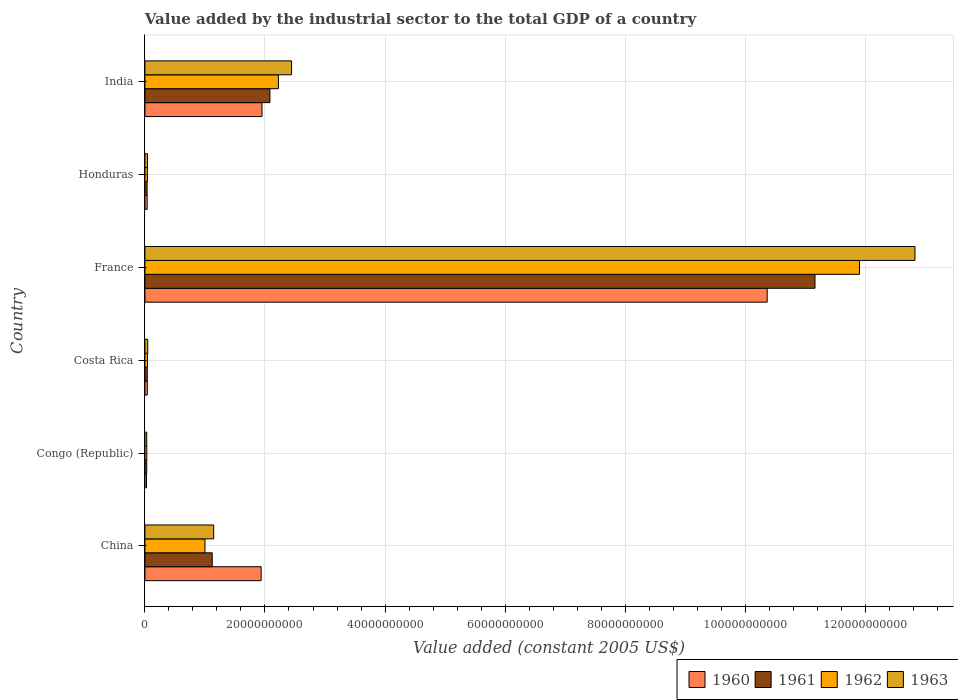How many different coloured bars are there?
Make the answer very short. 4. How many bars are there on the 2nd tick from the bottom?
Offer a terse response. 4. What is the label of the 2nd group of bars from the top?
Provide a succinct answer. Honduras. In how many cases, is the number of bars for a given country not equal to the number of legend labels?
Your answer should be very brief. 0. What is the value added by the industrial sector in 1961 in France?
Give a very brief answer. 1.12e+11. Across all countries, what is the maximum value added by the industrial sector in 1960?
Your answer should be very brief. 1.04e+11. Across all countries, what is the minimum value added by the industrial sector in 1962?
Provide a succinct answer. 3.12e+08. In which country was the value added by the industrial sector in 1962 minimum?
Offer a very short reply. Congo (Republic). What is the total value added by the industrial sector in 1960 in the graph?
Make the answer very short. 1.44e+11. What is the difference between the value added by the industrial sector in 1962 in China and that in France?
Offer a very short reply. -1.09e+11. What is the difference between the value added by the industrial sector in 1960 in India and the value added by the industrial sector in 1962 in Congo (Republic)?
Keep it short and to the point. 1.92e+1. What is the average value added by the industrial sector in 1963 per country?
Your response must be concise. 2.76e+1. What is the difference between the value added by the industrial sector in 1961 and value added by the industrial sector in 1962 in Congo (Republic)?
Your answer should be compact. -1.47e+07. In how many countries, is the value added by the industrial sector in 1960 greater than 100000000000 US$?
Your response must be concise. 1. What is the ratio of the value added by the industrial sector in 1962 in Congo (Republic) to that in France?
Offer a terse response. 0. Is the value added by the industrial sector in 1960 in Costa Rica less than that in India?
Your answer should be very brief. Yes. Is the difference between the value added by the industrial sector in 1961 in France and India greater than the difference between the value added by the industrial sector in 1962 in France and India?
Offer a very short reply. No. What is the difference between the highest and the second highest value added by the industrial sector in 1963?
Give a very brief answer. 1.04e+11. What is the difference between the highest and the lowest value added by the industrial sector in 1961?
Provide a short and direct response. 1.11e+11. In how many countries, is the value added by the industrial sector in 1960 greater than the average value added by the industrial sector in 1960 taken over all countries?
Provide a succinct answer. 1. How many bars are there?
Keep it short and to the point. 24. What is the difference between two consecutive major ticks on the X-axis?
Your answer should be compact. 2.00e+1. Are the values on the major ticks of X-axis written in scientific E-notation?
Your response must be concise. No. Does the graph contain any zero values?
Ensure brevity in your answer.  No. How many legend labels are there?
Your answer should be very brief. 4. How are the legend labels stacked?
Your answer should be very brief. Horizontal. What is the title of the graph?
Make the answer very short. Value added by the industrial sector to the total GDP of a country. Does "2003" appear as one of the legend labels in the graph?
Offer a very short reply. No. What is the label or title of the X-axis?
Make the answer very short. Value added (constant 2005 US$). What is the Value added (constant 2005 US$) of 1960 in China?
Your response must be concise. 1.94e+1. What is the Value added (constant 2005 US$) in 1961 in China?
Your response must be concise. 1.12e+1. What is the Value added (constant 2005 US$) of 1962 in China?
Keep it short and to the point. 1.00e+1. What is the Value added (constant 2005 US$) of 1963 in China?
Your answer should be very brief. 1.15e+1. What is the Value added (constant 2005 US$) of 1960 in Congo (Republic)?
Keep it short and to the point. 2.61e+08. What is the Value added (constant 2005 US$) of 1961 in Congo (Republic)?
Ensure brevity in your answer.  2.98e+08. What is the Value added (constant 2005 US$) in 1962 in Congo (Republic)?
Provide a succinct answer. 3.12e+08. What is the Value added (constant 2005 US$) in 1963 in Congo (Republic)?
Give a very brief answer. 3.00e+08. What is the Value added (constant 2005 US$) in 1960 in Costa Rica?
Your response must be concise. 3.98e+08. What is the Value added (constant 2005 US$) of 1961 in Costa Rica?
Your response must be concise. 3.94e+08. What is the Value added (constant 2005 US$) of 1962 in Costa Rica?
Provide a short and direct response. 4.27e+08. What is the Value added (constant 2005 US$) of 1963 in Costa Rica?
Make the answer very short. 4.68e+08. What is the Value added (constant 2005 US$) in 1960 in France?
Provide a succinct answer. 1.04e+11. What is the Value added (constant 2005 US$) of 1961 in France?
Your response must be concise. 1.12e+11. What is the Value added (constant 2005 US$) of 1962 in France?
Provide a short and direct response. 1.19e+11. What is the Value added (constant 2005 US$) of 1963 in France?
Your answer should be very brief. 1.28e+11. What is the Value added (constant 2005 US$) of 1960 in Honduras?
Provide a succinct answer. 3.75e+08. What is the Value added (constant 2005 US$) in 1961 in Honduras?
Offer a very short reply. 3.66e+08. What is the Value added (constant 2005 US$) in 1962 in Honduras?
Ensure brevity in your answer.  4.16e+08. What is the Value added (constant 2005 US$) in 1963 in Honduras?
Make the answer very short. 4.23e+08. What is the Value added (constant 2005 US$) in 1960 in India?
Your answer should be compact. 1.95e+1. What is the Value added (constant 2005 US$) of 1961 in India?
Give a very brief answer. 2.08e+1. What is the Value added (constant 2005 US$) in 1962 in India?
Keep it short and to the point. 2.22e+1. What is the Value added (constant 2005 US$) of 1963 in India?
Make the answer very short. 2.44e+1. Across all countries, what is the maximum Value added (constant 2005 US$) in 1960?
Your answer should be very brief. 1.04e+11. Across all countries, what is the maximum Value added (constant 2005 US$) in 1961?
Offer a very short reply. 1.12e+11. Across all countries, what is the maximum Value added (constant 2005 US$) of 1962?
Provide a short and direct response. 1.19e+11. Across all countries, what is the maximum Value added (constant 2005 US$) in 1963?
Your answer should be compact. 1.28e+11. Across all countries, what is the minimum Value added (constant 2005 US$) of 1960?
Your answer should be very brief. 2.61e+08. Across all countries, what is the minimum Value added (constant 2005 US$) of 1961?
Make the answer very short. 2.98e+08. Across all countries, what is the minimum Value added (constant 2005 US$) in 1962?
Offer a very short reply. 3.12e+08. Across all countries, what is the minimum Value added (constant 2005 US$) in 1963?
Your answer should be very brief. 3.00e+08. What is the total Value added (constant 2005 US$) of 1960 in the graph?
Offer a very short reply. 1.44e+11. What is the total Value added (constant 2005 US$) of 1961 in the graph?
Your answer should be very brief. 1.45e+11. What is the total Value added (constant 2005 US$) of 1962 in the graph?
Offer a terse response. 1.52e+11. What is the total Value added (constant 2005 US$) of 1963 in the graph?
Your answer should be compact. 1.65e+11. What is the difference between the Value added (constant 2005 US$) of 1960 in China and that in Congo (Republic)?
Your answer should be compact. 1.91e+1. What is the difference between the Value added (constant 2005 US$) in 1961 in China and that in Congo (Republic)?
Your answer should be compact. 1.09e+1. What is the difference between the Value added (constant 2005 US$) in 1962 in China and that in Congo (Republic)?
Keep it short and to the point. 9.69e+09. What is the difference between the Value added (constant 2005 US$) of 1963 in China and that in Congo (Republic)?
Keep it short and to the point. 1.12e+1. What is the difference between the Value added (constant 2005 US$) in 1960 in China and that in Costa Rica?
Your answer should be compact. 1.90e+1. What is the difference between the Value added (constant 2005 US$) in 1961 in China and that in Costa Rica?
Keep it short and to the point. 1.08e+1. What is the difference between the Value added (constant 2005 US$) in 1962 in China and that in Costa Rica?
Ensure brevity in your answer.  9.58e+09. What is the difference between the Value added (constant 2005 US$) in 1963 in China and that in Costa Rica?
Provide a succinct answer. 1.10e+1. What is the difference between the Value added (constant 2005 US$) of 1960 in China and that in France?
Provide a short and direct response. -8.43e+1. What is the difference between the Value added (constant 2005 US$) of 1961 in China and that in France?
Your answer should be compact. -1.00e+11. What is the difference between the Value added (constant 2005 US$) in 1962 in China and that in France?
Your answer should be compact. -1.09e+11. What is the difference between the Value added (constant 2005 US$) in 1963 in China and that in France?
Offer a very short reply. -1.17e+11. What is the difference between the Value added (constant 2005 US$) in 1960 in China and that in Honduras?
Provide a short and direct response. 1.90e+1. What is the difference between the Value added (constant 2005 US$) in 1961 in China and that in Honduras?
Your answer should be very brief. 1.08e+1. What is the difference between the Value added (constant 2005 US$) of 1962 in China and that in Honduras?
Offer a terse response. 9.59e+09. What is the difference between the Value added (constant 2005 US$) in 1963 in China and that in Honduras?
Make the answer very short. 1.10e+1. What is the difference between the Value added (constant 2005 US$) of 1960 in China and that in India?
Your answer should be very brief. -1.35e+08. What is the difference between the Value added (constant 2005 US$) in 1961 in China and that in India?
Offer a very short reply. -9.61e+09. What is the difference between the Value added (constant 2005 US$) of 1962 in China and that in India?
Provide a short and direct response. -1.22e+1. What is the difference between the Value added (constant 2005 US$) in 1963 in China and that in India?
Your response must be concise. -1.30e+1. What is the difference between the Value added (constant 2005 US$) in 1960 in Congo (Republic) and that in Costa Rica?
Offer a very short reply. -1.36e+08. What is the difference between the Value added (constant 2005 US$) of 1961 in Congo (Republic) and that in Costa Rica?
Your answer should be compact. -9.59e+07. What is the difference between the Value added (constant 2005 US$) in 1962 in Congo (Republic) and that in Costa Rica?
Make the answer very short. -1.14e+08. What is the difference between the Value added (constant 2005 US$) of 1963 in Congo (Republic) and that in Costa Rica?
Give a very brief answer. -1.68e+08. What is the difference between the Value added (constant 2005 US$) of 1960 in Congo (Republic) and that in France?
Offer a very short reply. -1.03e+11. What is the difference between the Value added (constant 2005 US$) of 1961 in Congo (Republic) and that in France?
Your answer should be compact. -1.11e+11. What is the difference between the Value added (constant 2005 US$) in 1962 in Congo (Republic) and that in France?
Offer a very short reply. -1.19e+11. What is the difference between the Value added (constant 2005 US$) in 1963 in Congo (Republic) and that in France?
Ensure brevity in your answer.  -1.28e+11. What is the difference between the Value added (constant 2005 US$) of 1960 in Congo (Republic) and that in Honduras?
Give a very brief answer. -1.14e+08. What is the difference between the Value added (constant 2005 US$) of 1961 in Congo (Republic) and that in Honduras?
Your response must be concise. -6.81e+07. What is the difference between the Value added (constant 2005 US$) of 1962 in Congo (Republic) and that in Honduras?
Keep it short and to the point. -1.03e+08. What is the difference between the Value added (constant 2005 US$) of 1963 in Congo (Republic) and that in Honduras?
Ensure brevity in your answer.  -1.23e+08. What is the difference between the Value added (constant 2005 US$) in 1960 in Congo (Republic) and that in India?
Provide a short and direct response. -1.92e+1. What is the difference between the Value added (constant 2005 US$) of 1961 in Congo (Republic) and that in India?
Give a very brief answer. -2.05e+1. What is the difference between the Value added (constant 2005 US$) in 1962 in Congo (Republic) and that in India?
Provide a succinct answer. -2.19e+1. What is the difference between the Value added (constant 2005 US$) in 1963 in Congo (Republic) and that in India?
Make the answer very short. -2.41e+1. What is the difference between the Value added (constant 2005 US$) of 1960 in Costa Rica and that in France?
Offer a very short reply. -1.03e+11. What is the difference between the Value added (constant 2005 US$) in 1961 in Costa Rica and that in France?
Your response must be concise. -1.11e+11. What is the difference between the Value added (constant 2005 US$) in 1962 in Costa Rica and that in France?
Make the answer very short. -1.19e+11. What is the difference between the Value added (constant 2005 US$) in 1963 in Costa Rica and that in France?
Keep it short and to the point. -1.28e+11. What is the difference between the Value added (constant 2005 US$) in 1960 in Costa Rica and that in Honduras?
Make the answer very short. 2.26e+07. What is the difference between the Value added (constant 2005 US$) in 1961 in Costa Rica and that in Honduras?
Your response must be concise. 2.78e+07. What is the difference between the Value added (constant 2005 US$) in 1962 in Costa Rica and that in Honduras?
Offer a very short reply. 1.10e+07. What is the difference between the Value added (constant 2005 US$) of 1963 in Costa Rica and that in Honduras?
Offer a terse response. 4.49e+07. What is the difference between the Value added (constant 2005 US$) of 1960 in Costa Rica and that in India?
Make the answer very short. -1.91e+1. What is the difference between the Value added (constant 2005 US$) of 1961 in Costa Rica and that in India?
Your answer should be very brief. -2.04e+1. What is the difference between the Value added (constant 2005 US$) in 1962 in Costa Rica and that in India?
Give a very brief answer. -2.18e+1. What is the difference between the Value added (constant 2005 US$) of 1963 in Costa Rica and that in India?
Offer a terse response. -2.40e+1. What is the difference between the Value added (constant 2005 US$) of 1960 in France and that in Honduras?
Give a very brief answer. 1.03e+11. What is the difference between the Value added (constant 2005 US$) in 1961 in France and that in Honduras?
Provide a succinct answer. 1.11e+11. What is the difference between the Value added (constant 2005 US$) of 1962 in France and that in Honduras?
Your answer should be compact. 1.19e+11. What is the difference between the Value added (constant 2005 US$) of 1963 in France and that in Honduras?
Keep it short and to the point. 1.28e+11. What is the difference between the Value added (constant 2005 US$) in 1960 in France and that in India?
Provide a succinct answer. 8.42e+1. What is the difference between the Value added (constant 2005 US$) in 1961 in France and that in India?
Keep it short and to the point. 9.08e+1. What is the difference between the Value added (constant 2005 US$) in 1962 in France and that in India?
Your answer should be compact. 9.68e+1. What is the difference between the Value added (constant 2005 US$) in 1963 in France and that in India?
Offer a terse response. 1.04e+11. What is the difference between the Value added (constant 2005 US$) in 1960 in Honduras and that in India?
Your response must be concise. -1.91e+1. What is the difference between the Value added (constant 2005 US$) in 1961 in Honduras and that in India?
Your response must be concise. -2.05e+1. What is the difference between the Value added (constant 2005 US$) in 1962 in Honduras and that in India?
Give a very brief answer. -2.18e+1. What is the difference between the Value added (constant 2005 US$) of 1963 in Honduras and that in India?
Your answer should be compact. -2.40e+1. What is the difference between the Value added (constant 2005 US$) in 1960 in China and the Value added (constant 2005 US$) in 1961 in Congo (Republic)?
Give a very brief answer. 1.91e+1. What is the difference between the Value added (constant 2005 US$) in 1960 in China and the Value added (constant 2005 US$) in 1962 in Congo (Republic)?
Your response must be concise. 1.91e+1. What is the difference between the Value added (constant 2005 US$) of 1960 in China and the Value added (constant 2005 US$) of 1963 in Congo (Republic)?
Ensure brevity in your answer.  1.91e+1. What is the difference between the Value added (constant 2005 US$) of 1961 in China and the Value added (constant 2005 US$) of 1962 in Congo (Republic)?
Provide a succinct answer. 1.09e+1. What is the difference between the Value added (constant 2005 US$) in 1961 in China and the Value added (constant 2005 US$) in 1963 in Congo (Republic)?
Offer a very short reply. 1.09e+1. What is the difference between the Value added (constant 2005 US$) of 1962 in China and the Value added (constant 2005 US$) of 1963 in Congo (Republic)?
Offer a very short reply. 9.70e+09. What is the difference between the Value added (constant 2005 US$) in 1960 in China and the Value added (constant 2005 US$) in 1961 in Costa Rica?
Make the answer very short. 1.90e+1. What is the difference between the Value added (constant 2005 US$) in 1960 in China and the Value added (constant 2005 US$) in 1962 in Costa Rica?
Your answer should be very brief. 1.89e+1. What is the difference between the Value added (constant 2005 US$) in 1960 in China and the Value added (constant 2005 US$) in 1963 in Costa Rica?
Provide a short and direct response. 1.89e+1. What is the difference between the Value added (constant 2005 US$) of 1961 in China and the Value added (constant 2005 US$) of 1962 in Costa Rica?
Keep it short and to the point. 1.08e+1. What is the difference between the Value added (constant 2005 US$) in 1961 in China and the Value added (constant 2005 US$) in 1963 in Costa Rica?
Your answer should be compact. 1.07e+1. What is the difference between the Value added (constant 2005 US$) of 1962 in China and the Value added (constant 2005 US$) of 1963 in Costa Rica?
Make the answer very short. 9.53e+09. What is the difference between the Value added (constant 2005 US$) in 1960 in China and the Value added (constant 2005 US$) in 1961 in France?
Make the answer very short. -9.23e+1. What is the difference between the Value added (constant 2005 US$) of 1960 in China and the Value added (constant 2005 US$) of 1962 in France?
Make the answer very short. -9.97e+1. What is the difference between the Value added (constant 2005 US$) of 1960 in China and the Value added (constant 2005 US$) of 1963 in France?
Your answer should be compact. -1.09e+11. What is the difference between the Value added (constant 2005 US$) in 1961 in China and the Value added (constant 2005 US$) in 1962 in France?
Your answer should be compact. -1.08e+11. What is the difference between the Value added (constant 2005 US$) of 1961 in China and the Value added (constant 2005 US$) of 1963 in France?
Provide a succinct answer. -1.17e+11. What is the difference between the Value added (constant 2005 US$) of 1962 in China and the Value added (constant 2005 US$) of 1963 in France?
Your answer should be very brief. -1.18e+11. What is the difference between the Value added (constant 2005 US$) in 1960 in China and the Value added (constant 2005 US$) in 1961 in Honduras?
Offer a terse response. 1.90e+1. What is the difference between the Value added (constant 2005 US$) of 1960 in China and the Value added (constant 2005 US$) of 1962 in Honduras?
Offer a very short reply. 1.90e+1. What is the difference between the Value added (constant 2005 US$) of 1960 in China and the Value added (constant 2005 US$) of 1963 in Honduras?
Your answer should be very brief. 1.89e+1. What is the difference between the Value added (constant 2005 US$) in 1961 in China and the Value added (constant 2005 US$) in 1962 in Honduras?
Ensure brevity in your answer.  1.08e+1. What is the difference between the Value added (constant 2005 US$) of 1961 in China and the Value added (constant 2005 US$) of 1963 in Honduras?
Provide a short and direct response. 1.08e+1. What is the difference between the Value added (constant 2005 US$) in 1962 in China and the Value added (constant 2005 US$) in 1963 in Honduras?
Provide a succinct answer. 9.58e+09. What is the difference between the Value added (constant 2005 US$) in 1960 in China and the Value added (constant 2005 US$) in 1961 in India?
Make the answer very short. -1.46e+09. What is the difference between the Value added (constant 2005 US$) in 1960 in China and the Value added (constant 2005 US$) in 1962 in India?
Provide a succinct answer. -2.88e+09. What is the difference between the Value added (constant 2005 US$) of 1960 in China and the Value added (constant 2005 US$) of 1963 in India?
Ensure brevity in your answer.  -5.06e+09. What is the difference between the Value added (constant 2005 US$) in 1961 in China and the Value added (constant 2005 US$) in 1962 in India?
Provide a succinct answer. -1.10e+1. What is the difference between the Value added (constant 2005 US$) of 1961 in China and the Value added (constant 2005 US$) of 1963 in India?
Give a very brief answer. -1.32e+1. What is the difference between the Value added (constant 2005 US$) in 1962 in China and the Value added (constant 2005 US$) in 1963 in India?
Your answer should be very brief. -1.44e+1. What is the difference between the Value added (constant 2005 US$) in 1960 in Congo (Republic) and the Value added (constant 2005 US$) in 1961 in Costa Rica?
Give a very brief answer. -1.32e+08. What is the difference between the Value added (constant 2005 US$) of 1960 in Congo (Republic) and the Value added (constant 2005 US$) of 1962 in Costa Rica?
Ensure brevity in your answer.  -1.65e+08. What is the difference between the Value added (constant 2005 US$) of 1960 in Congo (Republic) and the Value added (constant 2005 US$) of 1963 in Costa Rica?
Make the answer very short. -2.07e+08. What is the difference between the Value added (constant 2005 US$) of 1961 in Congo (Republic) and the Value added (constant 2005 US$) of 1962 in Costa Rica?
Offer a very short reply. -1.29e+08. What is the difference between the Value added (constant 2005 US$) in 1961 in Congo (Republic) and the Value added (constant 2005 US$) in 1963 in Costa Rica?
Your answer should be very brief. -1.70e+08. What is the difference between the Value added (constant 2005 US$) in 1962 in Congo (Republic) and the Value added (constant 2005 US$) in 1963 in Costa Rica?
Ensure brevity in your answer.  -1.56e+08. What is the difference between the Value added (constant 2005 US$) of 1960 in Congo (Republic) and the Value added (constant 2005 US$) of 1961 in France?
Your answer should be compact. -1.11e+11. What is the difference between the Value added (constant 2005 US$) in 1960 in Congo (Republic) and the Value added (constant 2005 US$) in 1962 in France?
Your response must be concise. -1.19e+11. What is the difference between the Value added (constant 2005 US$) of 1960 in Congo (Republic) and the Value added (constant 2005 US$) of 1963 in France?
Your answer should be compact. -1.28e+11. What is the difference between the Value added (constant 2005 US$) of 1961 in Congo (Republic) and the Value added (constant 2005 US$) of 1962 in France?
Your response must be concise. -1.19e+11. What is the difference between the Value added (constant 2005 US$) in 1961 in Congo (Republic) and the Value added (constant 2005 US$) in 1963 in France?
Ensure brevity in your answer.  -1.28e+11. What is the difference between the Value added (constant 2005 US$) of 1962 in Congo (Republic) and the Value added (constant 2005 US$) of 1963 in France?
Provide a succinct answer. -1.28e+11. What is the difference between the Value added (constant 2005 US$) of 1960 in Congo (Republic) and the Value added (constant 2005 US$) of 1961 in Honduras?
Give a very brief answer. -1.04e+08. What is the difference between the Value added (constant 2005 US$) of 1960 in Congo (Republic) and the Value added (constant 2005 US$) of 1962 in Honduras?
Provide a succinct answer. -1.54e+08. What is the difference between the Value added (constant 2005 US$) of 1960 in Congo (Republic) and the Value added (constant 2005 US$) of 1963 in Honduras?
Ensure brevity in your answer.  -1.62e+08. What is the difference between the Value added (constant 2005 US$) of 1961 in Congo (Republic) and the Value added (constant 2005 US$) of 1962 in Honduras?
Your answer should be very brief. -1.18e+08. What is the difference between the Value added (constant 2005 US$) in 1961 in Congo (Republic) and the Value added (constant 2005 US$) in 1963 in Honduras?
Offer a terse response. -1.25e+08. What is the difference between the Value added (constant 2005 US$) in 1962 in Congo (Republic) and the Value added (constant 2005 US$) in 1963 in Honduras?
Your answer should be very brief. -1.11e+08. What is the difference between the Value added (constant 2005 US$) of 1960 in Congo (Republic) and the Value added (constant 2005 US$) of 1961 in India?
Offer a terse response. -2.06e+1. What is the difference between the Value added (constant 2005 US$) in 1960 in Congo (Republic) and the Value added (constant 2005 US$) in 1962 in India?
Offer a very short reply. -2.20e+1. What is the difference between the Value added (constant 2005 US$) of 1960 in Congo (Republic) and the Value added (constant 2005 US$) of 1963 in India?
Provide a succinct answer. -2.42e+1. What is the difference between the Value added (constant 2005 US$) of 1961 in Congo (Republic) and the Value added (constant 2005 US$) of 1962 in India?
Offer a very short reply. -2.19e+1. What is the difference between the Value added (constant 2005 US$) in 1961 in Congo (Republic) and the Value added (constant 2005 US$) in 1963 in India?
Make the answer very short. -2.41e+1. What is the difference between the Value added (constant 2005 US$) of 1962 in Congo (Republic) and the Value added (constant 2005 US$) of 1963 in India?
Give a very brief answer. -2.41e+1. What is the difference between the Value added (constant 2005 US$) of 1960 in Costa Rica and the Value added (constant 2005 US$) of 1961 in France?
Provide a short and direct response. -1.11e+11. What is the difference between the Value added (constant 2005 US$) in 1960 in Costa Rica and the Value added (constant 2005 US$) in 1962 in France?
Provide a succinct answer. -1.19e+11. What is the difference between the Value added (constant 2005 US$) in 1960 in Costa Rica and the Value added (constant 2005 US$) in 1963 in France?
Offer a terse response. -1.28e+11. What is the difference between the Value added (constant 2005 US$) of 1961 in Costa Rica and the Value added (constant 2005 US$) of 1962 in France?
Offer a terse response. -1.19e+11. What is the difference between the Value added (constant 2005 US$) of 1961 in Costa Rica and the Value added (constant 2005 US$) of 1963 in France?
Your answer should be compact. -1.28e+11. What is the difference between the Value added (constant 2005 US$) of 1962 in Costa Rica and the Value added (constant 2005 US$) of 1963 in France?
Provide a succinct answer. -1.28e+11. What is the difference between the Value added (constant 2005 US$) in 1960 in Costa Rica and the Value added (constant 2005 US$) in 1961 in Honduras?
Give a very brief answer. 3.20e+07. What is the difference between the Value added (constant 2005 US$) of 1960 in Costa Rica and the Value added (constant 2005 US$) of 1962 in Honduras?
Give a very brief answer. -1.81e+07. What is the difference between the Value added (constant 2005 US$) of 1960 in Costa Rica and the Value added (constant 2005 US$) of 1963 in Honduras?
Give a very brief answer. -2.52e+07. What is the difference between the Value added (constant 2005 US$) in 1961 in Costa Rica and the Value added (constant 2005 US$) in 1962 in Honduras?
Your response must be concise. -2.22e+07. What is the difference between the Value added (constant 2005 US$) of 1961 in Costa Rica and the Value added (constant 2005 US$) of 1963 in Honduras?
Offer a very short reply. -2.94e+07. What is the difference between the Value added (constant 2005 US$) in 1962 in Costa Rica and the Value added (constant 2005 US$) in 1963 in Honduras?
Your answer should be compact. 3.81e+06. What is the difference between the Value added (constant 2005 US$) in 1960 in Costa Rica and the Value added (constant 2005 US$) in 1961 in India?
Offer a terse response. -2.04e+1. What is the difference between the Value added (constant 2005 US$) in 1960 in Costa Rica and the Value added (constant 2005 US$) in 1962 in India?
Your answer should be very brief. -2.18e+1. What is the difference between the Value added (constant 2005 US$) of 1960 in Costa Rica and the Value added (constant 2005 US$) of 1963 in India?
Provide a short and direct response. -2.40e+1. What is the difference between the Value added (constant 2005 US$) of 1961 in Costa Rica and the Value added (constant 2005 US$) of 1962 in India?
Ensure brevity in your answer.  -2.19e+1. What is the difference between the Value added (constant 2005 US$) in 1961 in Costa Rica and the Value added (constant 2005 US$) in 1963 in India?
Keep it short and to the point. -2.40e+1. What is the difference between the Value added (constant 2005 US$) in 1962 in Costa Rica and the Value added (constant 2005 US$) in 1963 in India?
Make the answer very short. -2.40e+1. What is the difference between the Value added (constant 2005 US$) of 1960 in France and the Value added (constant 2005 US$) of 1961 in Honduras?
Your response must be concise. 1.03e+11. What is the difference between the Value added (constant 2005 US$) in 1960 in France and the Value added (constant 2005 US$) in 1962 in Honduras?
Provide a short and direct response. 1.03e+11. What is the difference between the Value added (constant 2005 US$) in 1960 in France and the Value added (constant 2005 US$) in 1963 in Honduras?
Give a very brief answer. 1.03e+11. What is the difference between the Value added (constant 2005 US$) in 1961 in France and the Value added (constant 2005 US$) in 1962 in Honduras?
Your answer should be very brief. 1.11e+11. What is the difference between the Value added (constant 2005 US$) of 1961 in France and the Value added (constant 2005 US$) of 1963 in Honduras?
Your response must be concise. 1.11e+11. What is the difference between the Value added (constant 2005 US$) in 1962 in France and the Value added (constant 2005 US$) in 1963 in Honduras?
Your answer should be very brief. 1.19e+11. What is the difference between the Value added (constant 2005 US$) of 1960 in France and the Value added (constant 2005 US$) of 1961 in India?
Your answer should be compact. 8.28e+1. What is the difference between the Value added (constant 2005 US$) in 1960 in France and the Value added (constant 2005 US$) in 1962 in India?
Offer a very short reply. 8.14e+1. What is the difference between the Value added (constant 2005 US$) of 1960 in France and the Value added (constant 2005 US$) of 1963 in India?
Your answer should be very brief. 7.92e+1. What is the difference between the Value added (constant 2005 US$) in 1961 in France and the Value added (constant 2005 US$) in 1962 in India?
Give a very brief answer. 8.94e+1. What is the difference between the Value added (constant 2005 US$) of 1961 in France and the Value added (constant 2005 US$) of 1963 in India?
Provide a succinct answer. 8.72e+1. What is the difference between the Value added (constant 2005 US$) of 1962 in France and the Value added (constant 2005 US$) of 1963 in India?
Give a very brief answer. 9.46e+1. What is the difference between the Value added (constant 2005 US$) of 1960 in Honduras and the Value added (constant 2005 US$) of 1961 in India?
Provide a succinct answer. -2.05e+1. What is the difference between the Value added (constant 2005 US$) of 1960 in Honduras and the Value added (constant 2005 US$) of 1962 in India?
Your response must be concise. -2.19e+1. What is the difference between the Value added (constant 2005 US$) of 1960 in Honduras and the Value added (constant 2005 US$) of 1963 in India?
Make the answer very short. -2.41e+1. What is the difference between the Value added (constant 2005 US$) of 1961 in Honduras and the Value added (constant 2005 US$) of 1962 in India?
Give a very brief answer. -2.19e+1. What is the difference between the Value added (constant 2005 US$) in 1961 in Honduras and the Value added (constant 2005 US$) in 1963 in India?
Offer a terse response. -2.41e+1. What is the difference between the Value added (constant 2005 US$) of 1962 in Honduras and the Value added (constant 2005 US$) of 1963 in India?
Ensure brevity in your answer.  -2.40e+1. What is the average Value added (constant 2005 US$) in 1960 per country?
Your answer should be compact. 2.39e+1. What is the average Value added (constant 2005 US$) of 1961 per country?
Your response must be concise. 2.41e+1. What is the average Value added (constant 2005 US$) in 1962 per country?
Offer a terse response. 2.54e+1. What is the average Value added (constant 2005 US$) of 1963 per country?
Offer a terse response. 2.76e+1. What is the difference between the Value added (constant 2005 US$) of 1960 and Value added (constant 2005 US$) of 1961 in China?
Ensure brevity in your answer.  8.15e+09. What is the difference between the Value added (constant 2005 US$) in 1960 and Value added (constant 2005 US$) in 1962 in China?
Your answer should be very brief. 9.36e+09. What is the difference between the Value added (constant 2005 US$) in 1960 and Value added (constant 2005 US$) in 1963 in China?
Keep it short and to the point. 7.91e+09. What is the difference between the Value added (constant 2005 US$) in 1961 and Value added (constant 2005 US$) in 1962 in China?
Your answer should be very brief. 1.21e+09. What is the difference between the Value added (constant 2005 US$) in 1961 and Value added (constant 2005 US$) in 1963 in China?
Provide a succinct answer. -2.39e+08. What is the difference between the Value added (constant 2005 US$) in 1962 and Value added (constant 2005 US$) in 1963 in China?
Give a very brief answer. -1.45e+09. What is the difference between the Value added (constant 2005 US$) of 1960 and Value added (constant 2005 US$) of 1961 in Congo (Republic)?
Offer a very short reply. -3.63e+07. What is the difference between the Value added (constant 2005 US$) of 1960 and Value added (constant 2005 US$) of 1962 in Congo (Republic)?
Provide a short and direct response. -5.10e+07. What is the difference between the Value added (constant 2005 US$) of 1960 and Value added (constant 2005 US$) of 1963 in Congo (Republic)?
Provide a short and direct response. -3.84e+07. What is the difference between the Value added (constant 2005 US$) of 1961 and Value added (constant 2005 US$) of 1962 in Congo (Republic)?
Your answer should be compact. -1.47e+07. What is the difference between the Value added (constant 2005 US$) of 1961 and Value added (constant 2005 US$) of 1963 in Congo (Republic)?
Your answer should be compact. -2.10e+06. What is the difference between the Value added (constant 2005 US$) in 1962 and Value added (constant 2005 US$) in 1963 in Congo (Republic)?
Your answer should be compact. 1.26e+07. What is the difference between the Value added (constant 2005 US$) in 1960 and Value added (constant 2005 US$) in 1961 in Costa Rica?
Offer a terse response. 4.19e+06. What is the difference between the Value added (constant 2005 US$) in 1960 and Value added (constant 2005 US$) in 1962 in Costa Rica?
Ensure brevity in your answer.  -2.91e+07. What is the difference between the Value added (constant 2005 US$) in 1960 and Value added (constant 2005 US$) in 1963 in Costa Rica?
Make the answer very short. -7.01e+07. What is the difference between the Value added (constant 2005 US$) of 1961 and Value added (constant 2005 US$) of 1962 in Costa Rica?
Your answer should be compact. -3.32e+07. What is the difference between the Value added (constant 2005 US$) of 1961 and Value added (constant 2005 US$) of 1963 in Costa Rica?
Ensure brevity in your answer.  -7.43e+07. What is the difference between the Value added (constant 2005 US$) of 1962 and Value added (constant 2005 US$) of 1963 in Costa Rica?
Offer a very short reply. -4.11e+07. What is the difference between the Value added (constant 2005 US$) of 1960 and Value added (constant 2005 US$) of 1961 in France?
Keep it short and to the point. -7.97e+09. What is the difference between the Value added (constant 2005 US$) in 1960 and Value added (constant 2005 US$) in 1962 in France?
Offer a very short reply. -1.54e+1. What is the difference between the Value added (constant 2005 US$) of 1960 and Value added (constant 2005 US$) of 1963 in France?
Your answer should be compact. -2.46e+1. What is the difference between the Value added (constant 2005 US$) of 1961 and Value added (constant 2005 US$) of 1962 in France?
Give a very brief answer. -7.41e+09. What is the difference between the Value added (constant 2005 US$) of 1961 and Value added (constant 2005 US$) of 1963 in France?
Offer a terse response. -1.67e+1. What is the difference between the Value added (constant 2005 US$) in 1962 and Value added (constant 2005 US$) in 1963 in France?
Make the answer very short. -9.25e+09. What is the difference between the Value added (constant 2005 US$) of 1960 and Value added (constant 2005 US$) of 1961 in Honduras?
Keep it short and to the point. 9.37e+06. What is the difference between the Value added (constant 2005 US$) of 1960 and Value added (constant 2005 US$) of 1962 in Honduras?
Provide a succinct answer. -4.07e+07. What is the difference between the Value added (constant 2005 US$) in 1960 and Value added (constant 2005 US$) in 1963 in Honduras?
Your answer should be compact. -4.79e+07. What is the difference between the Value added (constant 2005 US$) of 1961 and Value added (constant 2005 US$) of 1962 in Honduras?
Keep it short and to the point. -5.00e+07. What is the difference between the Value added (constant 2005 US$) of 1961 and Value added (constant 2005 US$) of 1963 in Honduras?
Your answer should be compact. -5.72e+07. What is the difference between the Value added (constant 2005 US$) of 1962 and Value added (constant 2005 US$) of 1963 in Honduras?
Ensure brevity in your answer.  -7.19e+06. What is the difference between the Value added (constant 2005 US$) in 1960 and Value added (constant 2005 US$) in 1961 in India?
Your response must be concise. -1.32e+09. What is the difference between the Value added (constant 2005 US$) of 1960 and Value added (constant 2005 US$) of 1962 in India?
Provide a succinct answer. -2.74e+09. What is the difference between the Value added (constant 2005 US$) of 1960 and Value added (constant 2005 US$) of 1963 in India?
Offer a terse response. -4.92e+09. What is the difference between the Value added (constant 2005 US$) of 1961 and Value added (constant 2005 US$) of 1962 in India?
Provide a short and direct response. -1.42e+09. What is the difference between the Value added (constant 2005 US$) of 1961 and Value added (constant 2005 US$) of 1963 in India?
Make the answer very short. -3.60e+09. What is the difference between the Value added (constant 2005 US$) in 1962 and Value added (constant 2005 US$) in 1963 in India?
Ensure brevity in your answer.  -2.18e+09. What is the ratio of the Value added (constant 2005 US$) in 1960 in China to that in Congo (Republic)?
Offer a very short reply. 74.09. What is the ratio of the Value added (constant 2005 US$) in 1961 in China to that in Congo (Republic)?
Provide a succinct answer. 37.67. What is the ratio of the Value added (constant 2005 US$) of 1962 in China to that in Congo (Republic)?
Your answer should be very brief. 32.02. What is the ratio of the Value added (constant 2005 US$) of 1963 in China to that in Congo (Republic)?
Your answer should be compact. 38.21. What is the ratio of the Value added (constant 2005 US$) of 1960 in China to that in Costa Rica?
Give a very brief answer. 48.69. What is the ratio of the Value added (constant 2005 US$) in 1961 in China to that in Costa Rica?
Offer a terse response. 28.49. What is the ratio of the Value added (constant 2005 US$) of 1962 in China to that in Costa Rica?
Offer a very short reply. 23.43. What is the ratio of the Value added (constant 2005 US$) in 1963 in China to that in Costa Rica?
Your response must be concise. 24.48. What is the ratio of the Value added (constant 2005 US$) of 1960 in China to that in France?
Your response must be concise. 0.19. What is the ratio of the Value added (constant 2005 US$) in 1961 in China to that in France?
Offer a very short reply. 0.1. What is the ratio of the Value added (constant 2005 US$) of 1962 in China to that in France?
Your response must be concise. 0.08. What is the ratio of the Value added (constant 2005 US$) of 1963 in China to that in France?
Make the answer very short. 0.09. What is the ratio of the Value added (constant 2005 US$) in 1960 in China to that in Honduras?
Offer a very short reply. 51.62. What is the ratio of the Value added (constant 2005 US$) in 1961 in China to that in Honduras?
Ensure brevity in your answer.  30.65. What is the ratio of the Value added (constant 2005 US$) in 1962 in China to that in Honduras?
Your answer should be very brief. 24.05. What is the ratio of the Value added (constant 2005 US$) in 1963 in China to that in Honduras?
Offer a very short reply. 27.07. What is the ratio of the Value added (constant 2005 US$) of 1960 in China to that in India?
Make the answer very short. 0.99. What is the ratio of the Value added (constant 2005 US$) in 1961 in China to that in India?
Provide a short and direct response. 0.54. What is the ratio of the Value added (constant 2005 US$) in 1962 in China to that in India?
Your answer should be very brief. 0.45. What is the ratio of the Value added (constant 2005 US$) of 1963 in China to that in India?
Provide a succinct answer. 0.47. What is the ratio of the Value added (constant 2005 US$) in 1960 in Congo (Republic) to that in Costa Rica?
Offer a terse response. 0.66. What is the ratio of the Value added (constant 2005 US$) in 1961 in Congo (Republic) to that in Costa Rica?
Make the answer very short. 0.76. What is the ratio of the Value added (constant 2005 US$) in 1962 in Congo (Republic) to that in Costa Rica?
Provide a succinct answer. 0.73. What is the ratio of the Value added (constant 2005 US$) in 1963 in Congo (Republic) to that in Costa Rica?
Offer a very short reply. 0.64. What is the ratio of the Value added (constant 2005 US$) in 1960 in Congo (Republic) to that in France?
Make the answer very short. 0. What is the ratio of the Value added (constant 2005 US$) in 1961 in Congo (Republic) to that in France?
Offer a very short reply. 0. What is the ratio of the Value added (constant 2005 US$) of 1962 in Congo (Republic) to that in France?
Offer a very short reply. 0. What is the ratio of the Value added (constant 2005 US$) in 1963 in Congo (Republic) to that in France?
Provide a short and direct response. 0. What is the ratio of the Value added (constant 2005 US$) in 1960 in Congo (Republic) to that in Honduras?
Provide a succinct answer. 0.7. What is the ratio of the Value added (constant 2005 US$) of 1961 in Congo (Republic) to that in Honduras?
Your answer should be compact. 0.81. What is the ratio of the Value added (constant 2005 US$) in 1962 in Congo (Republic) to that in Honduras?
Make the answer very short. 0.75. What is the ratio of the Value added (constant 2005 US$) in 1963 in Congo (Republic) to that in Honduras?
Offer a terse response. 0.71. What is the ratio of the Value added (constant 2005 US$) in 1960 in Congo (Republic) to that in India?
Ensure brevity in your answer.  0.01. What is the ratio of the Value added (constant 2005 US$) of 1961 in Congo (Republic) to that in India?
Your answer should be compact. 0.01. What is the ratio of the Value added (constant 2005 US$) in 1962 in Congo (Republic) to that in India?
Ensure brevity in your answer.  0.01. What is the ratio of the Value added (constant 2005 US$) in 1963 in Congo (Republic) to that in India?
Your answer should be compact. 0.01. What is the ratio of the Value added (constant 2005 US$) of 1960 in Costa Rica to that in France?
Ensure brevity in your answer.  0. What is the ratio of the Value added (constant 2005 US$) in 1961 in Costa Rica to that in France?
Your response must be concise. 0. What is the ratio of the Value added (constant 2005 US$) of 1962 in Costa Rica to that in France?
Ensure brevity in your answer.  0. What is the ratio of the Value added (constant 2005 US$) of 1963 in Costa Rica to that in France?
Ensure brevity in your answer.  0. What is the ratio of the Value added (constant 2005 US$) of 1960 in Costa Rica to that in Honduras?
Provide a succinct answer. 1.06. What is the ratio of the Value added (constant 2005 US$) of 1961 in Costa Rica to that in Honduras?
Make the answer very short. 1.08. What is the ratio of the Value added (constant 2005 US$) in 1962 in Costa Rica to that in Honduras?
Your answer should be very brief. 1.03. What is the ratio of the Value added (constant 2005 US$) in 1963 in Costa Rica to that in Honduras?
Your answer should be very brief. 1.11. What is the ratio of the Value added (constant 2005 US$) in 1960 in Costa Rica to that in India?
Provide a short and direct response. 0.02. What is the ratio of the Value added (constant 2005 US$) of 1961 in Costa Rica to that in India?
Make the answer very short. 0.02. What is the ratio of the Value added (constant 2005 US$) in 1962 in Costa Rica to that in India?
Offer a very short reply. 0.02. What is the ratio of the Value added (constant 2005 US$) of 1963 in Costa Rica to that in India?
Your answer should be very brief. 0.02. What is the ratio of the Value added (constant 2005 US$) in 1960 in France to that in Honduras?
Offer a terse response. 276.31. What is the ratio of the Value added (constant 2005 US$) in 1961 in France to that in Honduras?
Make the answer very short. 305.16. What is the ratio of the Value added (constant 2005 US$) in 1962 in France to that in Honduras?
Provide a succinct answer. 286.26. What is the ratio of the Value added (constant 2005 US$) in 1963 in France to that in Honduras?
Provide a short and direct response. 303.25. What is the ratio of the Value added (constant 2005 US$) of 1960 in France to that in India?
Your response must be concise. 5.32. What is the ratio of the Value added (constant 2005 US$) in 1961 in France to that in India?
Keep it short and to the point. 5.36. What is the ratio of the Value added (constant 2005 US$) in 1962 in France to that in India?
Your response must be concise. 5.35. What is the ratio of the Value added (constant 2005 US$) of 1963 in France to that in India?
Provide a short and direct response. 5.25. What is the ratio of the Value added (constant 2005 US$) of 1960 in Honduras to that in India?
Your answer should be very brief. 0.02. What is the ratio of the Value added (constant 2005 US$) of 1961 in Honduras to that in India?
Your answer should be very brief. 0.02. What is the ratio of the Value added (constant 2005 US$) in 1962 in Honduras to that in India?
Ensure brevity in your answer.  0.02. What is the ratio of the Value added (constant 2005 US$) of 1963 in Honduras to that in India?
Give a very brief answer. 0.02. What is the difference between the highest and the second highest Value added (constant 2005 US$) in 1960?
Your answer should be very brief. 8.42e+1. What is the difference between the highest and the second highest Value added (constant 2005 US$) in 1961?
Your answer should be compact. 9.08e+1. What is the difference between the highest and the second highest Value added (constant 2005 US$) of 1962?
Provide a short and direct response. 9.68e+1. What is the difference between the highest and the second highest Value added (constant 2005 US$) in 1963?
Your answer should be very brief. 1.04e+11. What is the difference between the highest and the lowest Value added (constant 2005 US$) in 1960?
Your response must be concise. 1.03e+11. What is the difference between the highest and the lowest Value added (constant 2005 US$) in 1961?
Your answer should be very brief. 1.11e+11. What is the difference between the highest and the lowest Value added (constant 2005 US$) in 1962?
Offer a very short reply. 1.19e+11. What is the difference between the highest and the lowest Value added (constant 2005 US$) in 1963?
Your response must be concise. 1.28e+11. 